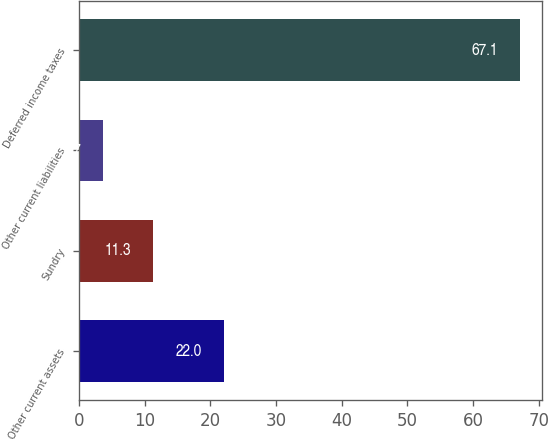Convert chart to OTSL. <chart><loc_0><loc_0><loc_500><loc_500><bar_chart><fcel>Other current assets<fcel>Sundry<fcel>Other current liabilities<fcel>Deferred income taxes<nl><fcel>22<fcel>11.3<fcel>3.7<fcel>67.1<nl></chart> 